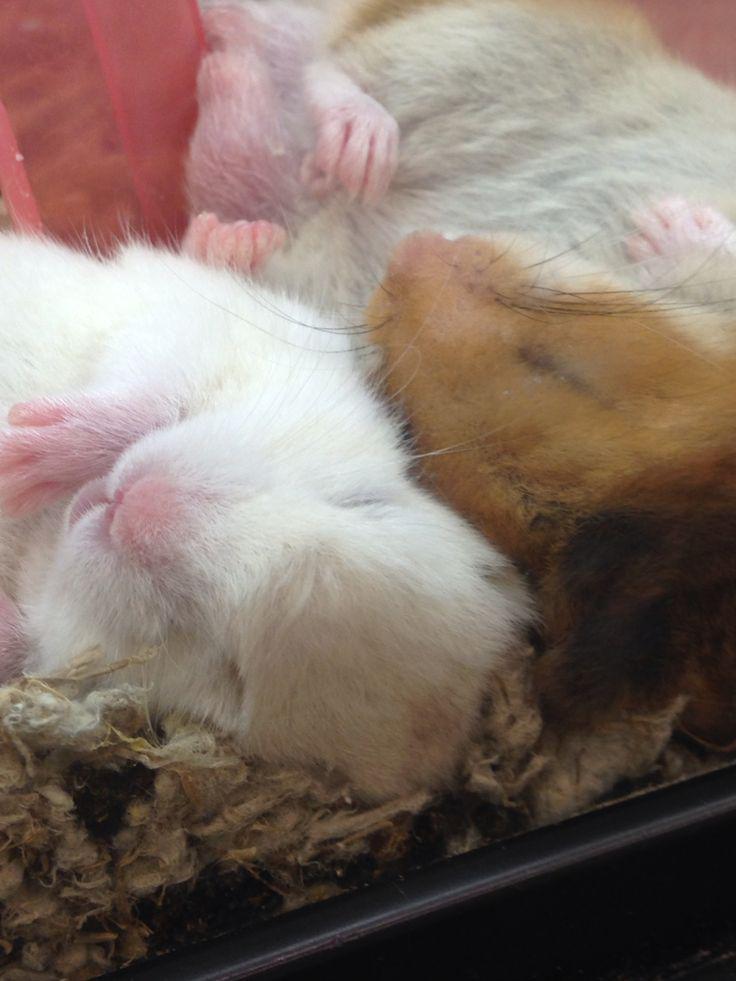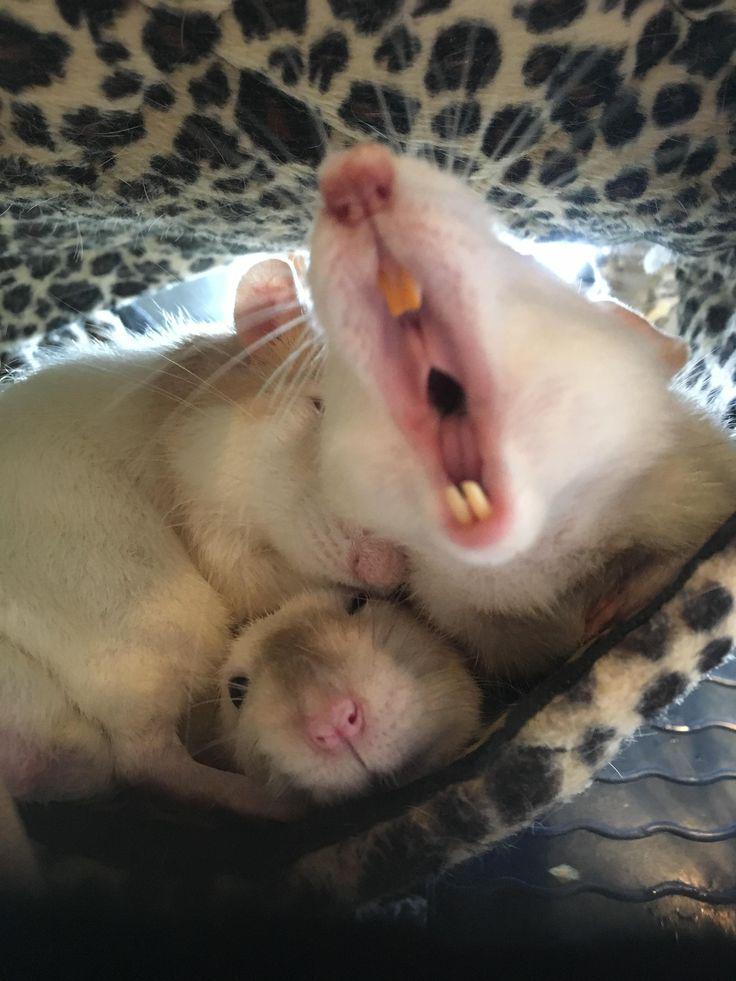The first image is the image on the left, the second image is the image on the right. Examine the images to the left and right. Is the description "Some of the hamsters are asleep." accurate? Answer yes or no. Yes. The first image is the image on the left, the second image is the image on the right. Analyze the images presented: Is the assertion "The left image shows two hamsters sleeping side-by-side with their eyes shut and paws facing upward." valid? Answer yes or no. Yes. 